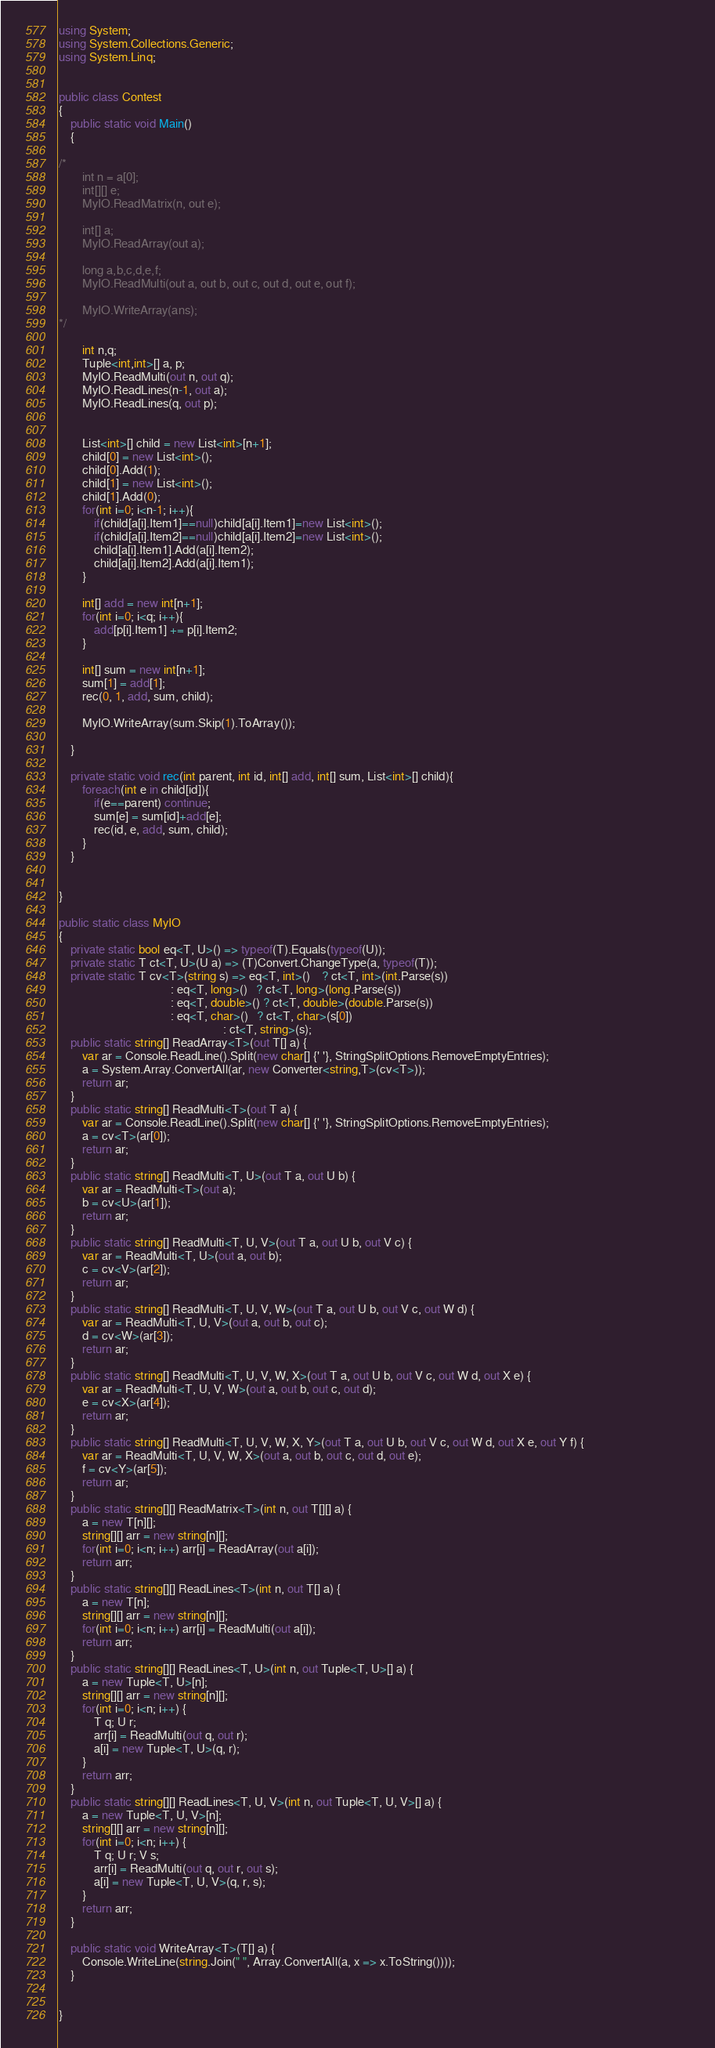<code> <loc_0><loc_0><loc_500><loc_500><_C#_>using System;
using System.Collections.Generic;
using System.Linq;


public class Contest
{
	public static void Main()
	{

/*
		int n = a[0];
		int[][] e;
		MyIO.ReadMatrix(n, out e);

		int[] a;
		MyIO.ReadArray(out a);

        long a,b,c,d,e,f;
        MyIO.ReadMulti(out a, out b, out c, out d, out e, out f);

		MyIO.WriteArray(ans);
*/

        int n,q;
		Tuple<int,int>[] a, p;
		MyIO.ReadMulti(out n, out q);
		MyIO.ReadLines(n-1, out a);
		MyIO.ReadLines(q, out p);


		List<int>[] child = new List<int>[n+1];
		child[0] = new List<int>();
		child[0].Add(1);
		child[1] = new List<int>();
		child[1].Add(0);
		for(int i=0; i<n-1; i++){
			if(child[a[i].Item1]==null)child[a[i].Item1]=new List<int>();
			if(child[a[i].Item2]==null)child[a[i].Item2]=new List<int>();
			child[a[i].Item1].Add(a[i].Item2);
			child[a[i].Item2].Add(a[i].Item1);
		}

		int[] add = new int[n+1];
		for(int i=0; i<q; i++){
			add[p[i].Item1] += p[i].Item2; 
		}

		int[] sum = new int[n+1];
		sum[1] = add[1];
		rec(0, 1, add, sum, child);

		MyIO.WriteArray(sum.Skip(1).ToArray());
		
	}

	private static void rec(int parent, int id, int[] add, int[] sum, List<int>[] child){
		foreach(int e in child[id]){
			if(e==parent) continue;
			sum[e] = sum[id]+add[e];
			rec(id, e, add, sum, child);
		}
	}


}

public static class MyIO
{
	private static bool eq<T, U>() => typeof(T).Equals(typeof(U));
	private static T ct<T, U>(U a) => (T)Convert.ChangeType(a, typeof(T));
	private static T cv<T>(string s) => eq<T, int>()    ? ct<T, int>(int.Parse(s))
	                                  : eq<T, long>()   ? ct<T, long>(long.Parse(s))
	                                  : eq<T, double>() ? ct<T, double>(double.Parse(s))
	                                  : eq<T, char>()   ? ct<T, char>(s[0])
	                                                    : ct<T, string>(s);
	public static string[] ReadArray<T>(out T[] a) {		
		var ar = Console.ReadLine().Split(new char[] {' '}, StringSplitOptions.RemoveEmptyEntries); 												
		a = System.Array.ConvertAll(ar, new Converter<string,T>(cv<T>));
		return ar;
	}										
	public static string[] ReadMulti<T>(out T a) {
		var ar = Console.ReadLine().Split(new char[] {' '}, StringSplitOptions.RemoveEmptyEntries); 
		a = cv<T>(ar[0]);
		return ar;
	}
	public static string[] ReadMulti<T, U>(out T a, out U b) {
		var ar = ReadMulti<T>(out a); 
        b = cv<U>(ar[1]);
		return ar;
	}
	public static string[] ReadMulti<T, U, V>(out T a, out U b, out V c) {
		var ar = ReadMulti<T, U>(out a, out b); 
        c = cv<V>(ar[2]);
		return ar;
	}
	public static string[] ReadMulti<T, U, V, W>(out T a, out U b, out V c, out W d) {
		var ar = ReadMulti<T, U, V>(out a, out b, out c); 
        d = cv<W>(ar[3]);
		return ar;
	}
	public static string[] ReadMulti<T, U, V, W, X>(out T a, out U b, out V c, out W d, out X e) {
		var ar = ReadMulti<T, U, V, W>(out a, out b, out c, out d); 
        e = cv<X>(ar[4]);
		return ar;
	}
	public static string[] ReadMulti<T, U, V, W, X, Y>(out T a, out U b, out V c, out W d, out X e, out Y f) {
		var ar = ReadMulti<T, U, V, W, X>(out a, out b, out c, out d, out e); 
        f = cv<Y>(ar[5]);
		return ar;
	}
	public static string[][] ReadMatrix<T>(int n, out T[][] a) {
		a = new T[n][];
		string[][] arr = new string[n][];
		for(int i=0; i<n; i++) arr[i] = ReadArray(out a[i]);
		return arr;
	}
	public static string[][] ReadLines<T>(int n, out T[] a) {
		a = new T[n];
		string[][] arr = new string[n][];
		for(int i=0; i<n; i++) arr[i] = ReadMulti(out a[i]);
		return arr;
	}
	public static string[][] ReadLines<T, U>(int n, out Tuple<T, U>[] a) {
		a = new Tuple<T, U>[n];
		string[][] arr = new string[n][];
		for(int i=0; i<n; i++) {
			T q; U r;
			arr[i] = ReadMulti(out q, out r);
			a[i] = new Tuple<T, U>(q, r);
		}
		return arr;
	}
	public static string[][] ReadLines<T, U, V>(int n, out Tuple<T, U, V>[] a) {
		a = new Tuple<T, U, V>[n];
		string[][] arr = new string[n][];
		for(int i=0; i<n; i++) {
			T q; U r; V s;
			arr[i] = ReadMulti(out q, out r, out s);
			a[i] = new Tuple<T, U, V>(q, r, s);
		}
		return arr;
	}

	public static void WriteArray<T>(T[] a) {
		Console.WriteLine(string.Join(" ", Array.ConvertAll(a, x => x.ToString())));
	}


}

</code> 